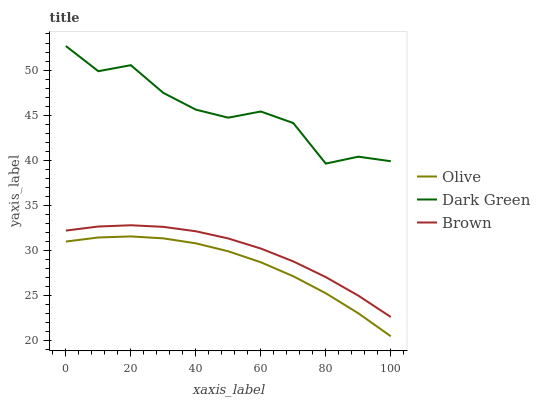Does Olive have the minimum area under the curve?
Answer yes or no. Yes. Does Dark Green have the maximum area under the curve?
Answer yes or no. Yes. Does Brown have the minimum area under the curve?
Answer yes or no. No. Does Brown have the maximum area under the curve?
Answer yes or no. No. Is Brown the smoothest?
Answer yes or no. Yes. Is Dark Green the roughest?
Answer yes or no. Yes. Is Dark Green the smoothest?
Answer yes or no. No. Is Brown the roughest?
Answer yes or no. No. Does Olive have the lowest value?
Answer yes or no. Yes. Does Brown have the lowest value?
Answer yes or no. No. Does Dark Green have the highest value?
Answer yes or no. Yes. Does Brown have the highest value?
Answer yes or no. No. Is Olive less than Dark Green?
Answer yes or no. Yes. Is Dark Green greater than Brown?
Answer yes or no. Yes. Does Olive intersect Dark Green?
Answer yes or no. No. 